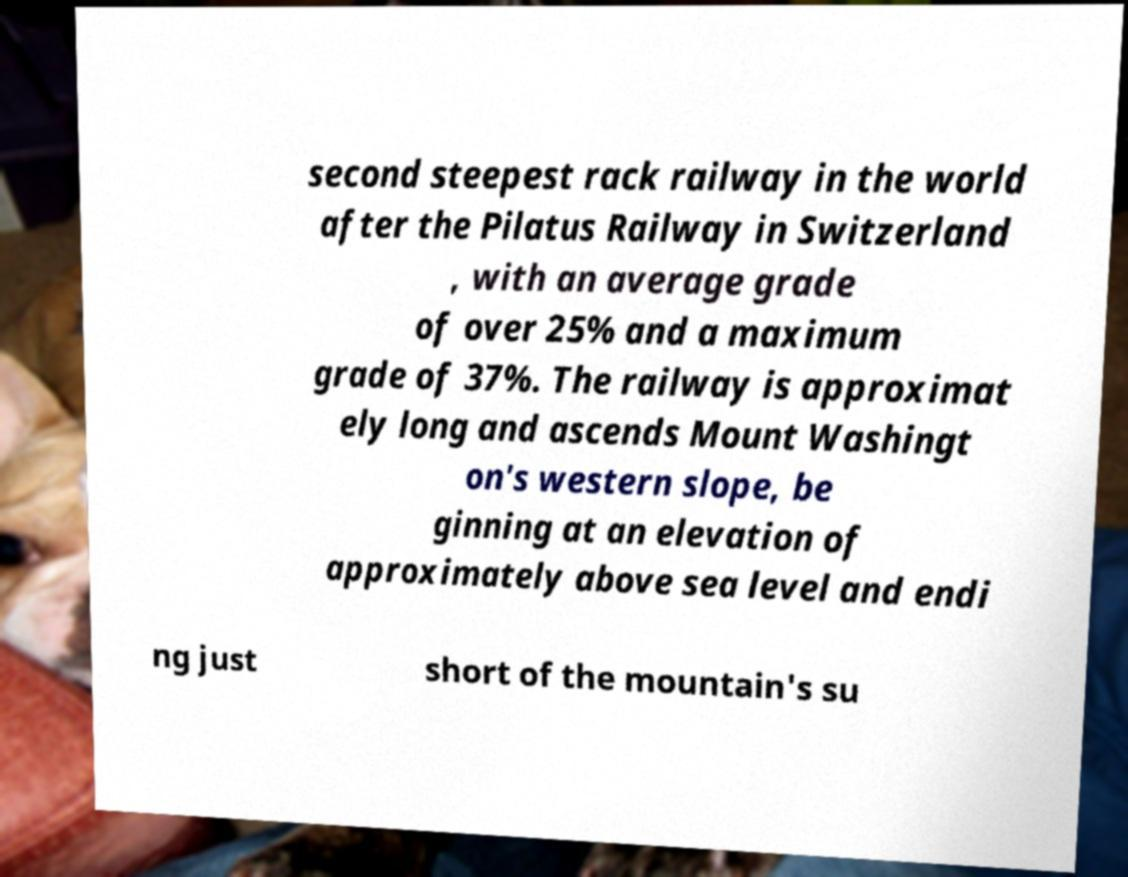Please identify and transcribe the text found in this image. second steepest rack railway in the world after the Pilatus Railway in Switzerland , with an average grade of over 25% and a maximum grade of 37%. The railway is approximat ely long and ascends Mount Washingt on's western slope, be ginning at an elevation of approximately above sea level and endi ng just short of the mountain's su 